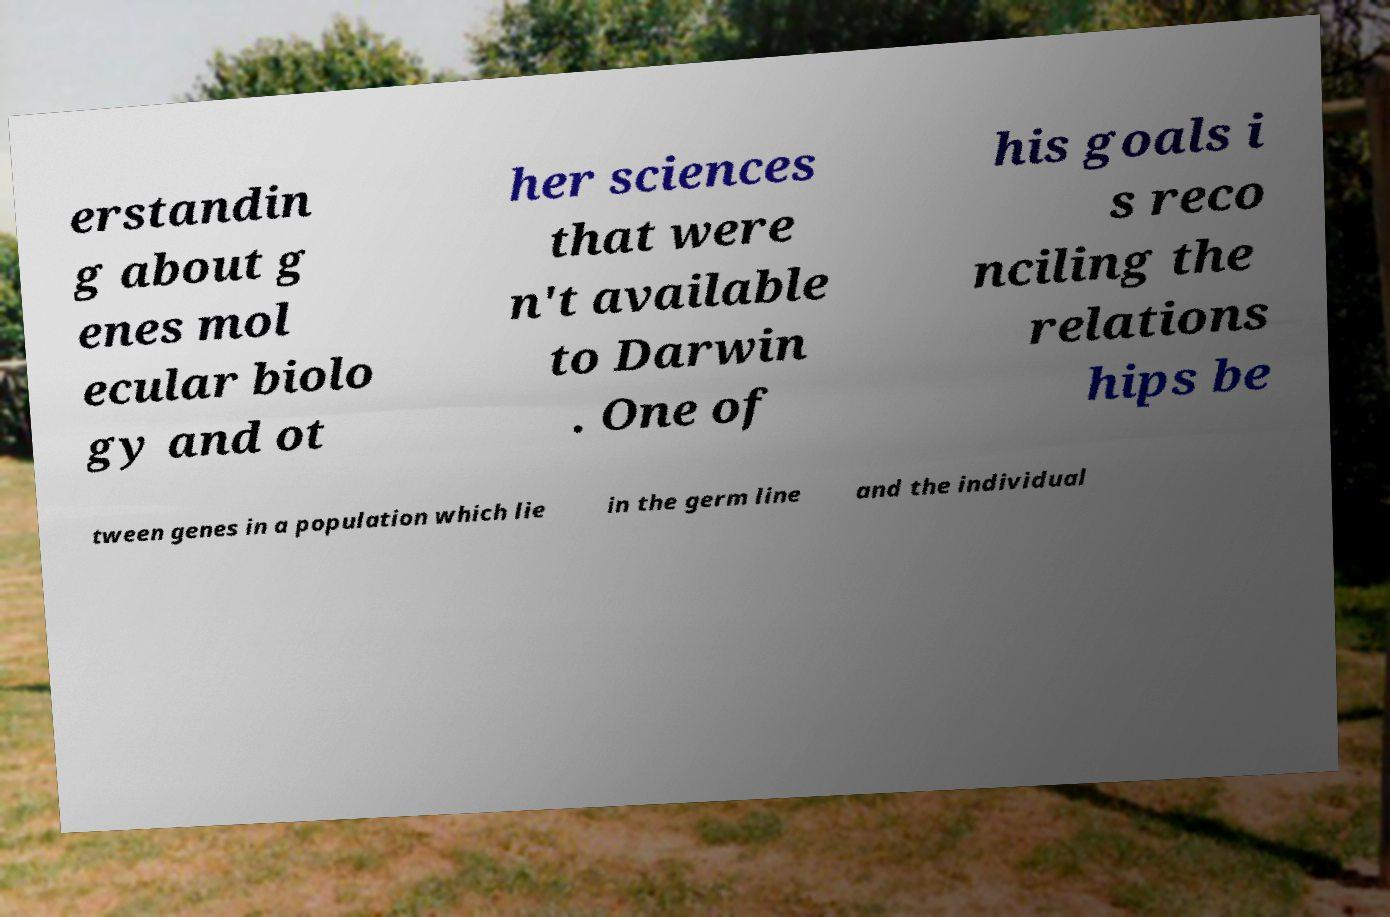Could you assist in decoding the text presented in this image and type it out clearly? erstandin g about g enes mol ecular biolo gy and ot her sciences that were n't available to Darwin . One of his goals i s reco nciling the relations hips be tween genes in a population which lie in the germ line and the individual 